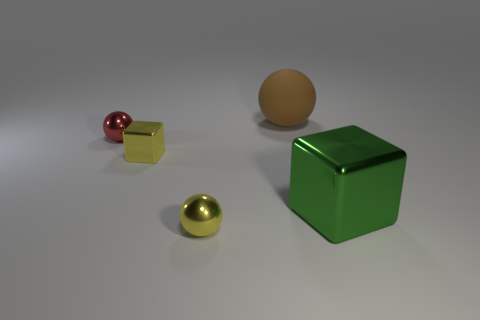Subtract all small spheres. How many spheres are left? 1 Add 2 large matte things. How many objects exist? 7 Subtract 1 spheres. How many spheres are left? 2 Subtract all blocks. How many objects are left? 3 Add 1 small metal objects. How many small metal objects are left? 4 Add 2 small metallic balls. How many small metallic balls exist? 4 Subtract 0 cyan blocks. How many objects are left? 5 Subtract all rubber balls. Subtract all brown matte things. How many objects are left? 3 